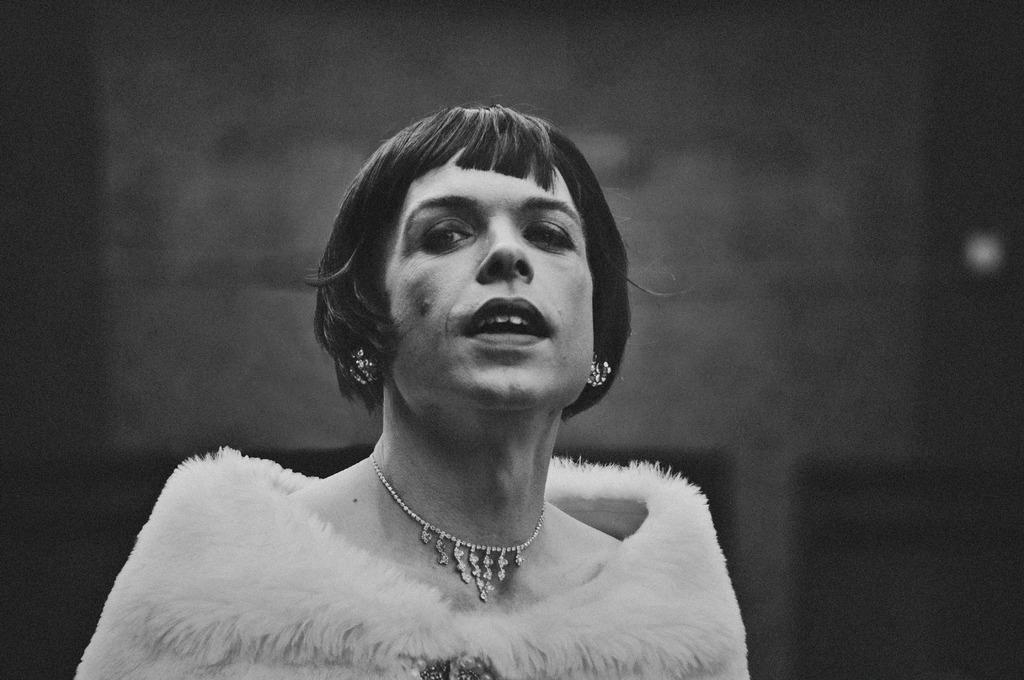How would you summarize this image in a sentence or two? In the image we can see there is a woman, she is wearing feather jacket and necklace. The image is in black and white colour. 